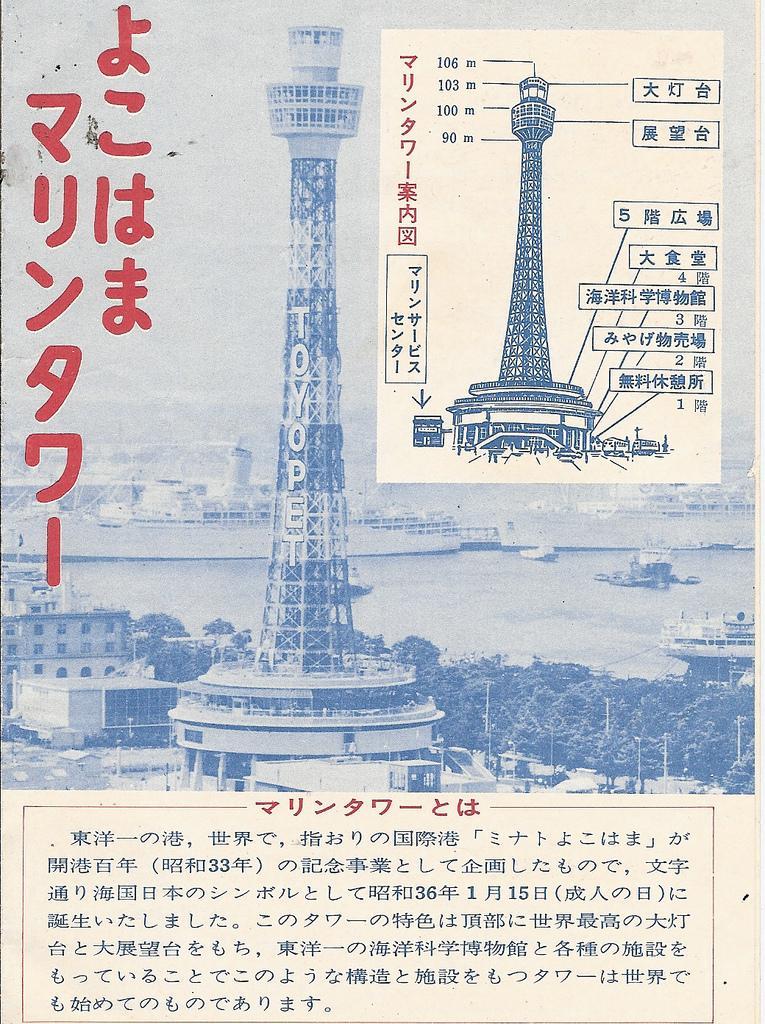Please provide a concise description of this image. This is a paper. On that there is an article. In that there are buildings, trees and water. In the water there are ships. Also something is written on that. 